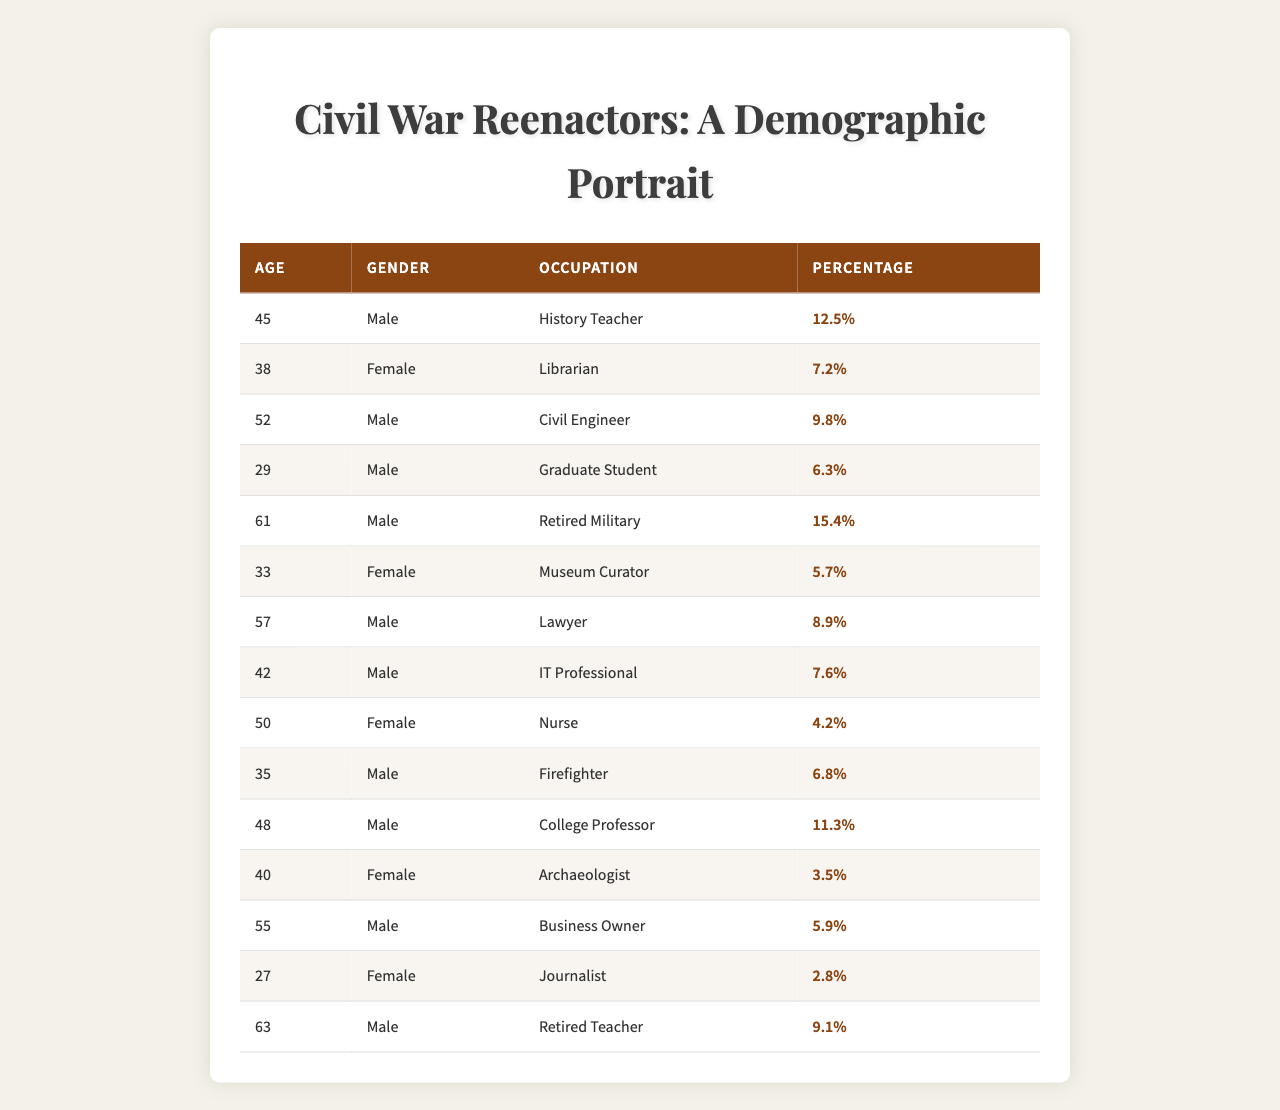What is the percentage of female reenactors? To find the percentage of female reenactors, we can look at the rows with "Female" in the Gender column. There are three female reenactors: a Librarian (7.2%), a Nurse (4.2%), and an Archaeologist (3.5%). We add these percentages together: 7.2 + 4.2 + 3.5 = 14.9%.
Answer: 14.9% How many males are Civil Engineers? The table shows there is only one entry with "Civil Engineer" as the occupation, and it belongs to a male who has a percentage of 9.8%. Therefore, there are no additional males listed as Civil Engineers.
Answer: 1 What is the average age of male reenactors? The ages of male reenactors are 45, 52, 61, 57, 42, 35, 48, 63. To find the average, we first sum these ages: 45 + 52 + 61 + 57 + 42 + 35 + 48 + 63 = 403. Then, we divide by the number of male reenactors, which is 8. The average is 403 / 8 = 50.375, rounded to 50.
Answer: 50.4 Are there any reenactors older than 60? We can examine the Age column to see if there are any ages above 60. The ages listed are 61 and 63, which confirm that there are indeed reenactors older than 60.
Answer: Yes What is the most common occupation among the reenactors? To find the most common occupation, we can look at the occupations and their corresponding percentages. The occupation with the highest percentage is "Retired Military," which has a percentage of 15.4%.
Answer: Retired Military How many total reenactors are represented in this demographic data? To get the total number of reenactors represented, we sum the percentages of all entries in the table: 12.5 + 7.2 + 9.8 + 6.3 + 15.4 + 5.7 + 8.9 + 7.6 + 4.2 + 6.8 + 11.3 + 3.5 + 5.9 + 2.8 + 9.1 = 100%. Thus, all data points contribute to the total.
Answer: 100% What percentage of the reenactors are either a teacher or a professor? We can check the relevant entries: "History Teacher" (12.5%) and "College Professor" (11.3%) are the roles we need. We add these two percentages: 12.5% + 11.3% = 23.8%.
Answer: 23.8% Which occupation has the highest percentage of representation? The row with the highest percentage is "Retired Military," which shows 15.4% in the table, making it the occupation with the highest representation.
Answer: Retired Military What is the difference between the percentages of the oldest and youngest reenactors? The youngest reenactor listed is 27 years old, a female Journalist at 2.8%. The oldest reenactor is 63, a male Retired Teacher at 9.1%. The difference is calculated as 9.1% - 2.8% = 6.3%.
Answer: 6.3% How many males have occupations related to education? The male occupations related to education are "History Teacher," "College Professor," and "Retired Teacher." The percentages for these are 12.5%, 11.3%, and 9.1% respectively. Therefore, there are three males with education-related occupations.
Answer: 3 